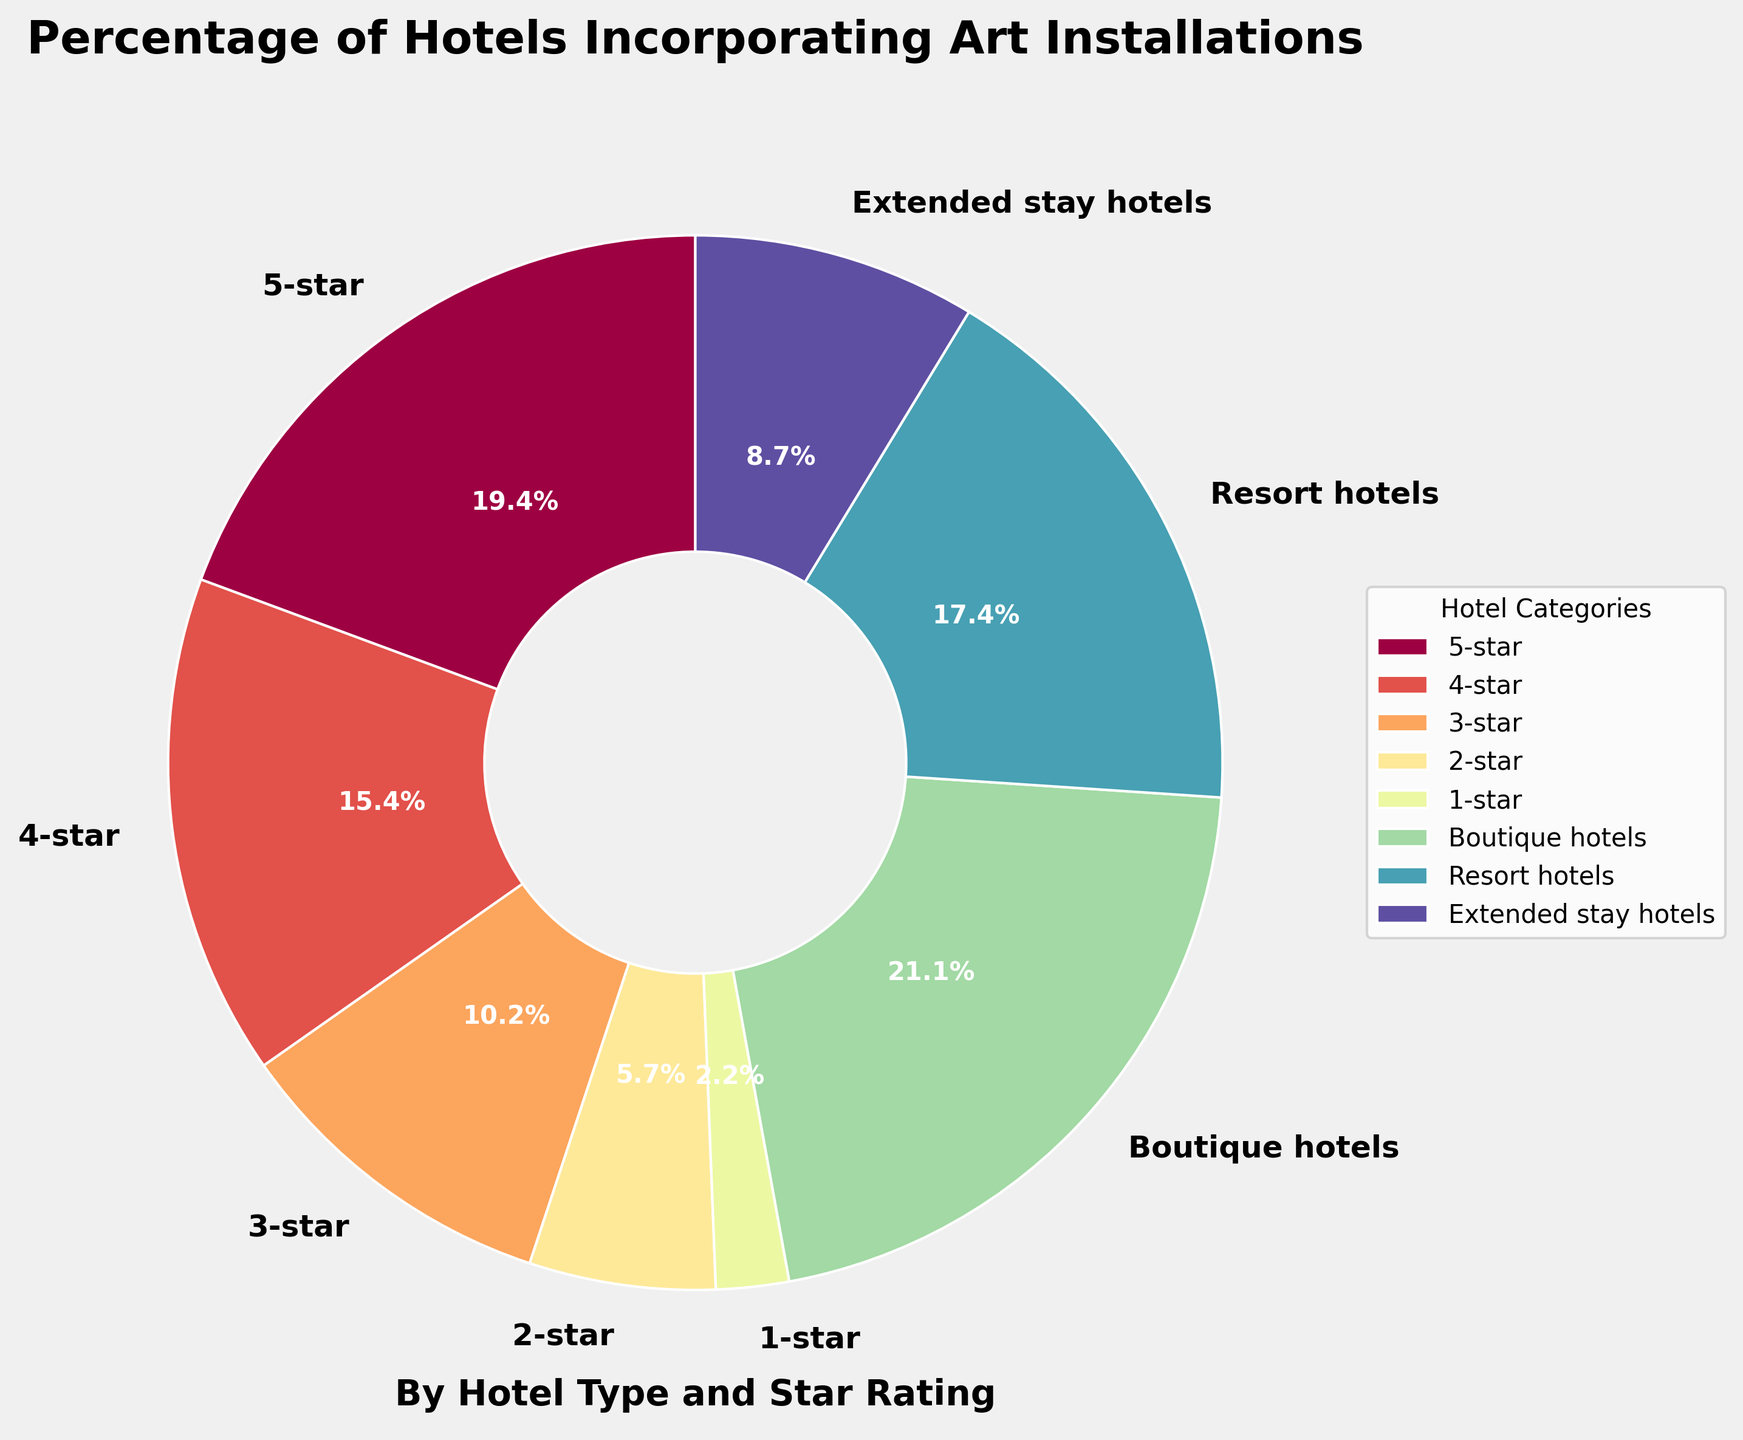Which hotel category has the largest percentage of art installations? According to the pie chart, the category with the largest segment is "Boutique hotels" with 85%
Answer: Boutique hotels What percentage of 3-star hotels have art installations compared to 5-star hotels? First, locate the percentages for 3-star and 5-star hotels. 3-star hotels = 41%, 5-star hotels = 78%. Then, compare them: 41% is significantly lower than 78%
Answer: 3-star: 41%, 5-star: 78% Which hotel category has the smallest percentage of art installations? The smallest segment in the pie chart is labeled "1-star" with 9%
Answer: 1-star Compare the percentage of art installations in resort hotels to boutique hotels. Which is higher and by how much? Boutique hotels have 85%, and resort hotels have 70%. Subtract to find the difference: 85% - 70% = 15%
Answer: Boutique hotels are higher by 15% Calculate the total percentage of art installations in 3-star and 4-star hotels combined. Add the given percentages: 3-star = 41%, 4-star = 62%. So, 41% + 62% = 103%
Answer: 103% What is the average percentage of art installations in 1-star, 2-star, and extended stay hotels? Add the percentages: 1-star (9%), 2-star (23%), extended stay hotels (35%). Then divide by number of categories: (9% + 23% + 35%) / 3 = 67% / 3 ≈ 22.3%
Answer: Approximately 22.3% Is the percentage of art installations in 2-star hotels closer to that in 3-star hotels or extended stay hotels? The percentage in 2-star hotels is 23%. Compare it to 3-star (41%) and extended stay hotels (35%). The difference with 3-star is 41%-23% = 18%; the difference with extended stay hotels is 35%-23% = 12%. 23% is closer to 35%
Answer: Extended stay hotels How does the percentage of art installations in 4-star hotels compare to resort hotels? 4-star hotels have 62%, and resort hotels have 70%. Resort hotels have an 8% higher percentage.
Answer: Resort hotels have an 8% higher percentage List the hotel categories in descending order based on the percentage of art installations. Arrange the percentages from highest to lowest: Boutique hotels (85%), 5-star (78%), Resort hotels (70%), 4-star (62%), 3-star (41%), Extended stay hotels (35%), 2-star (23%), 1-star (9%)
Answer: Boutique, 5-star, Resort, 4-star, 3-star, Extended stay, 2-star, 1-star If a hotel incorporates art installations, what is the probability it is a 4-star hotel? The percentage of 4-star hotels with art installations is 62%. To calculate the probability, assume 100 hotels; then 62 of them would be 4-star. Thus, the probability is 62/100 = 0.62 or 62%
Answer: 62% 